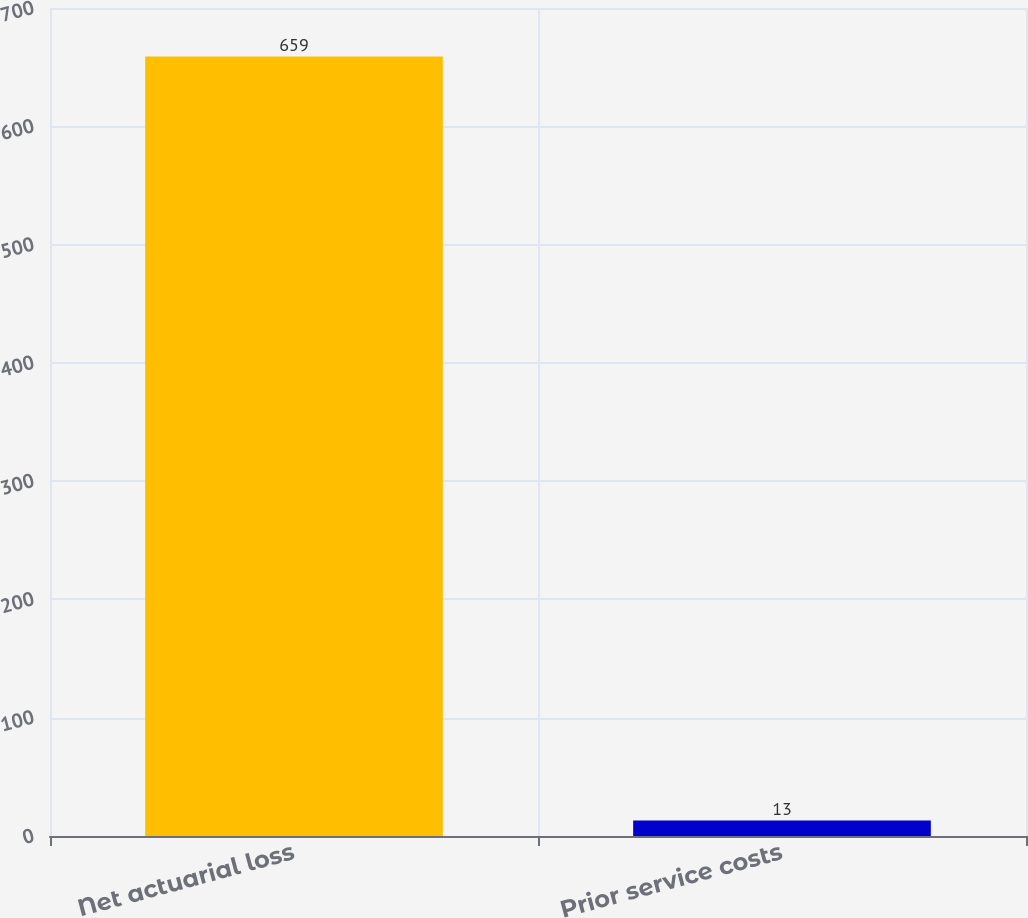Convert chart to OTSL. <chart><loc_0><loc_0><loc_500><loc_500><bar_chart><fcel>Net actuarial loss<fcel>Prior service costs<nl><fcel>659<fcel>13<nl></chart> 